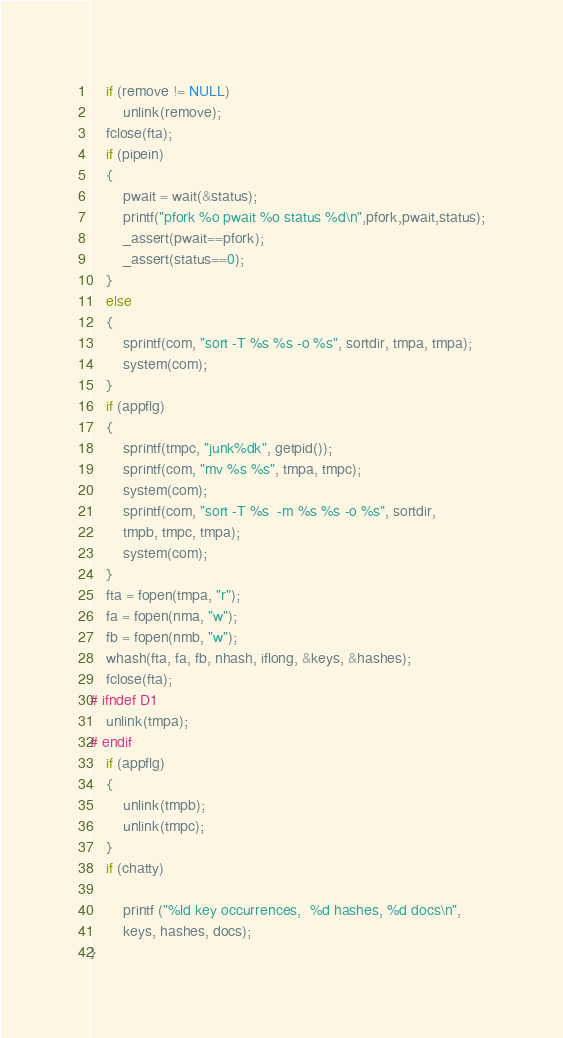<code> <loc_0><loc_0><loc_500><loc_500><_C_>	if (remove != NULL)
		unlink(remove);
	fclose(fta);
	if (pipein)
	{
		pwait = wait(&status);
		printf("pfork %o pwait %o status %d\n",pfork,pwait,status);
		_assert(pwait==pfork);
		_assert(status==0);
	}
	else
	{
		sprintf(com, "sort -T %s %s -o %s", sortdir, tmpa, tmpa);
		system(com);
	}
	if (appflg)
	{
		sprintf(tmpc, "junk%dk", getpid());
		sprintf(com, "mv %s %s", tmpa, tmpc);
		system(com);
		sprintf(com, "sort -T %s  -m %s %s -o %s", sortdir,
		tmpb, tmpc, tmpa);
		system(com);
	}
	fta = fopen(tmpa, "r");
	fa = fopen(nma, "w");
	fb = fopen(nmb, "w");
	whash(fta, fa, fb, nhash, iflong, &keys, &hashes);
	fclose(fta);
# ifndef D1
	unlink(tmpa);
# endif
	if (appflg)
	{
		unlink(tmpb);
		unlink(tmpc);
	}
	if (chatty)

		printf ("%ld key occurrences,  %d hashes, %d docs\n",
		keys, hashes, docs);
}
</code> 